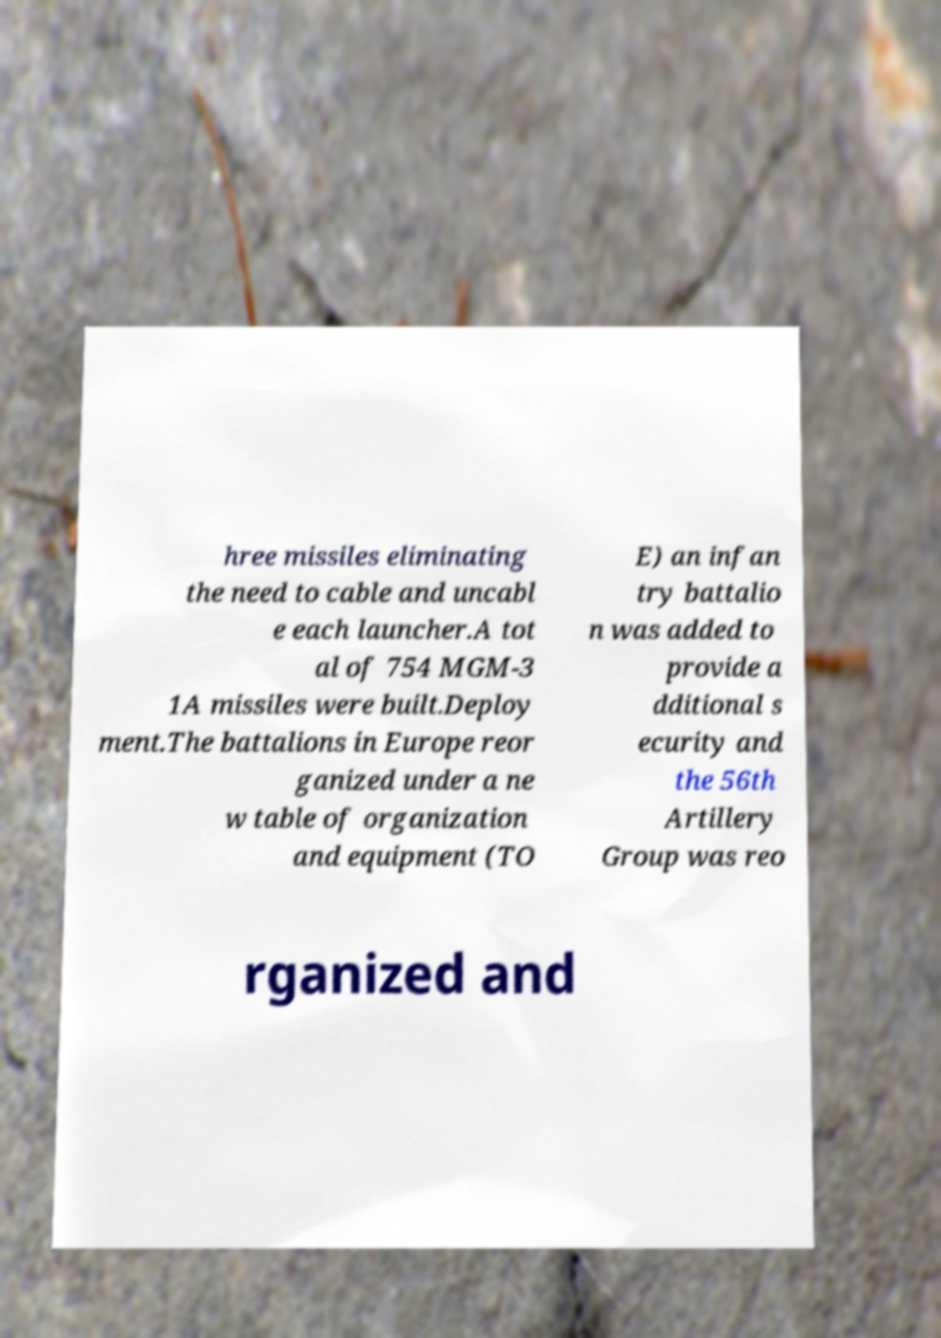There's text embedded in this image that I need extracted. Can you transcribe it verbatim? hree missiles eliminating the need to cable and uncabl e each launcher.A tot al of 754 MGM-3 1A missiles were built.Deploy ment.The battalions in Europe reor ganized under a ne w table of organization and equipment (TO E) an infan try battalio n was added to provide a dditional s ecurity and the 56th Artillery Group was reo rganized and 